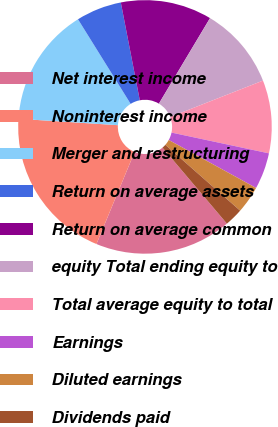Convert chart to OTSL. <chart><loc_0><loc_0><loc_500><loc_500><pie_chart><fcel>Net interest income<fcel>Noninterest income<fcel>Merger and restructuring<fcel>Return on average assets<fcel>Return on average common<fcel>equity Total ending equity to<fcel>Total average equity to total<fcel>Earnings<fcel>Diluted earnings<fcel>Dividends paid<nl><fcel>17.44%<fcel>19.77%<fcel>15.12%<fcel>5.81%<fcel>11.63%<fcel>10.47%<fcel>9.3%<fcel>4.65%<fcel>3.49%<fcel>2.33%<nl></chart> 